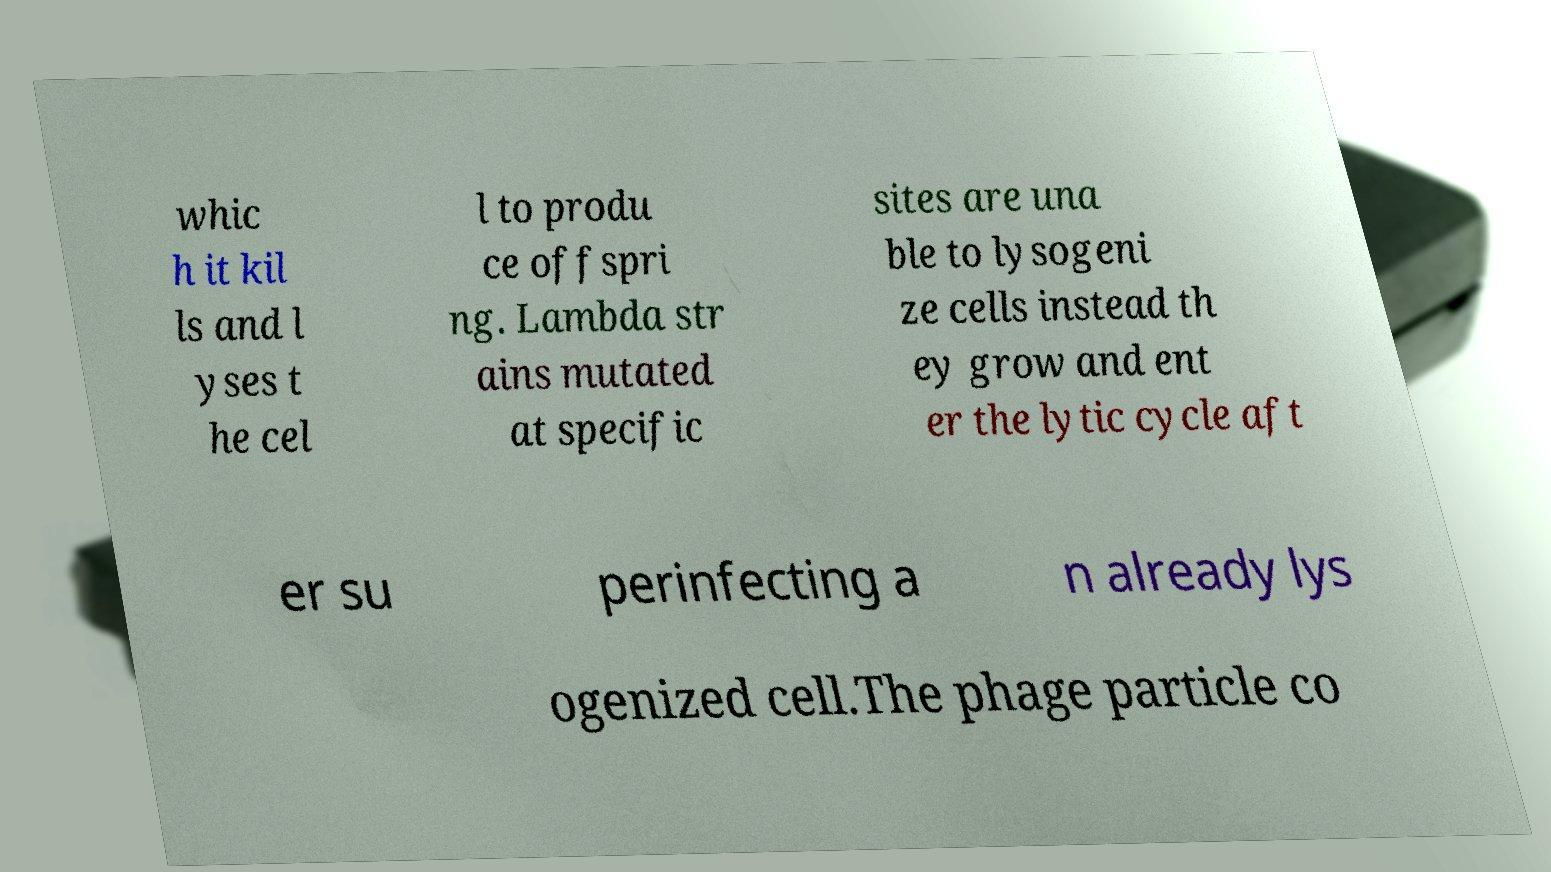There's text embedded in this image that I need extracted. Can you transcribe it verbatim? whic h it kil ls and l yses t he cel l to produ ce offspri ng. Lambda str ains mutated at specific sites are una ble to lysogeni ze cells instead th ey grow and ent er the lytic cycle aft er su perinfecting a n already lys ogenized cell.The phage particle co 